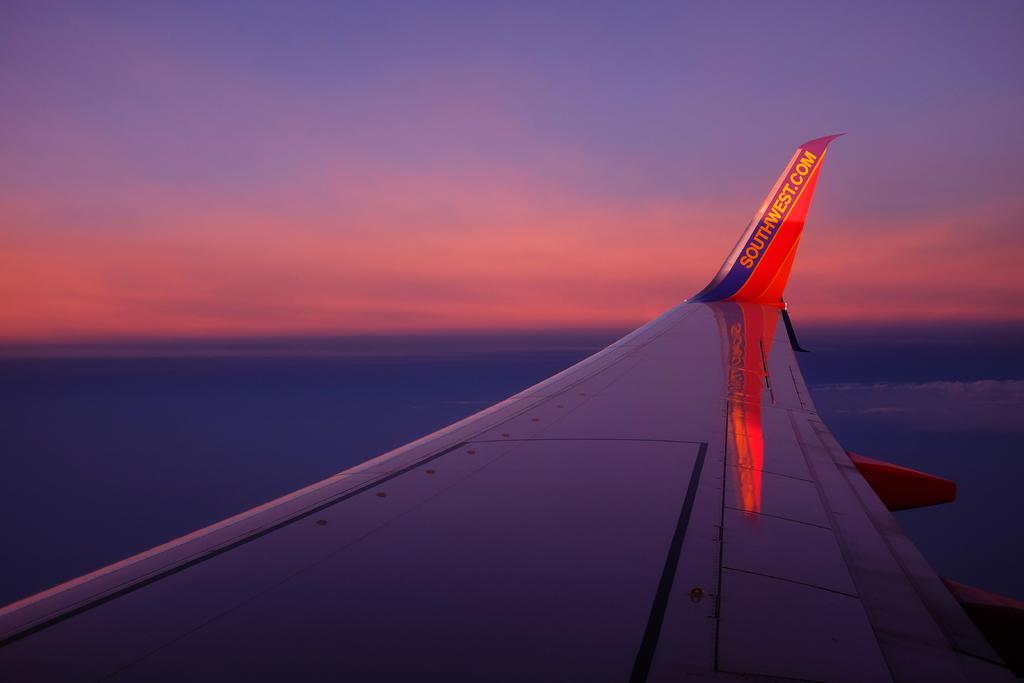<image>
Summarize the visual content of the image. A Southwest Airlines wing is soaring the clear sky during a beautiful pink sunset 